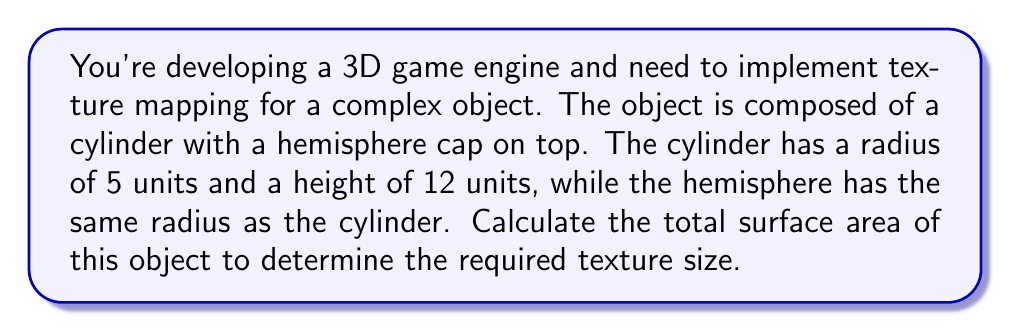Can you answer this question? Let's break this down step-by-step:

1. Surface area of the cylinder (excluding top and bottom):
   $$A_{cylinder} = 2\pi rh$$
   where $r$ is the radius and $h$ is the height
   $$A_{cylinder} = 2\pi \cdot 5 \cdot 12 = 120\pi$$

2. Surface area of the circular base of the cylinder:
   $$A_{base} = \pi r^2$$
   $$A_{base} = \pi \cdot 5^2 = 25\pi$$

3. Surface area of the hemisphere:
   $$A_{hemisphere} = 2\pi r^2$$
   $$A_{hemisphere} = 2\pi \cdot 5^2 = 50\pi$$

4. Total surface area:
   $$A_{total} = A_{cylinder} + A_{base} + A_{hemisphere}$$
   $$A_{total} = 120\pi + 25\pi + 50\pi = 195\pi$$

5. Simplify:
   $$A_{total} = 195\pi \approx 612.61 \text{ square units}$$

[asy]
import three;

size(200);
currentprojection=perspective(6,3,2);

draw(cylinder((0,0,0),5,12));
draw(shift(0,0,12)*surface(sphere(5)),lightblue);
draw(shift(0,0,12)*circle(O,5));
[/asy]
Answer: $195\pi$ square units 